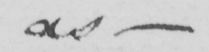Can you tell me what this handwritten text says? as  _ 